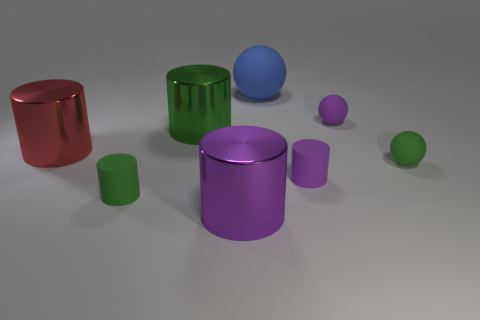There is a purple metal cylinder; is its size the same as the green metallic object in front of the small purple ball?
Provide a succinct answer. Yes. There is a green rubber thing that is behind the small green thing that is in front of the green matte sphere; what is its shape?
Your response must be concise. Sphere. Is the number of blue rubber spheres that are in front of the red metal cylinder less than the number of metallic things?
Your response must be concise. Yes. What number of green metallic objects have the same size as the blue sphere?
Provide a short and direct response. 1. The green thing to the right of the purple metal object has what shape?
Provide a succinct answer. Sphere. Are there fewer tiny purple cylinders than green blocks?
Provide a succinct answer. No. Is there any other thing of the same color as the big rubber thing?
Give a very brief answer. No. There is a cylinder that is in front of the tiny green cylinder; how big is it?
Provide a succinct answer. Large. Are there more big blue spheres than metal things?
Offer a very short reply. No. What is the material of the blue sphere?
Provide a succinct answer. Rubber. 